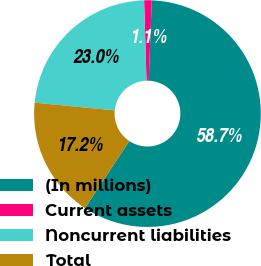Convert chart to OTSL. <chart><loc_0><loc_0><loc_500><loc_500><pie_chart><fcel>(In millions)<fcel>Current assets<fcel>Noncurrent liabilities<fcel>Total<nl><fcel>58.7%<fcel>1.08%<fcel>22.99%<fcel>17.23%<nl></chart> 